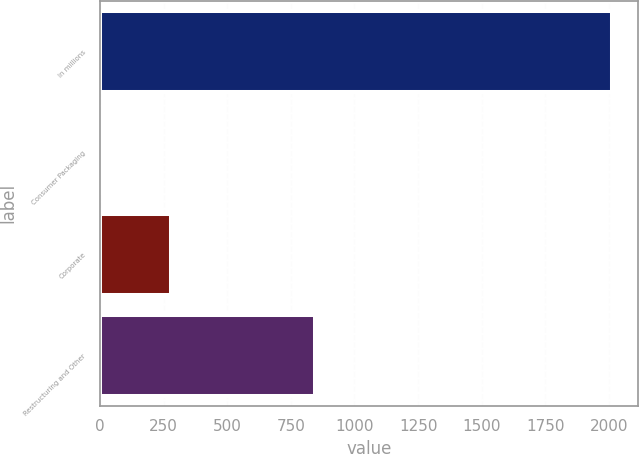Convert chart to OTSL. <chart><loc_0><loc_0><loc_500><loc_500><bar_chart><fcel>In millions<fcel>Consumer Packaging<fcel>Corporate<fcel>Restructuring and Other<nl><fcel>2014<fcel>8<fcel>277<fcel>846<nl></chart> 